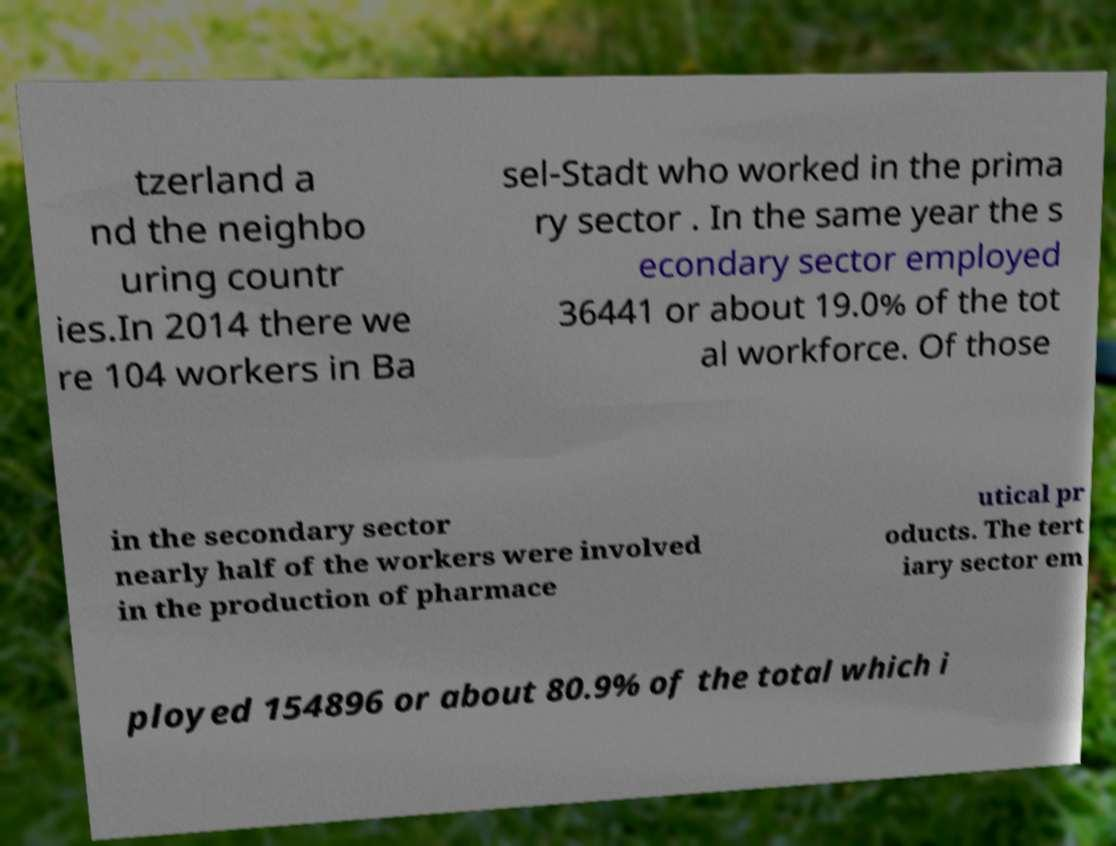What messages or text are displayed in this image? I need them in a readable, typed format. tzerland a nd the neighbo uring countr ies.In 2014 there we re 104 workers in Ba sel-Stadt who worked in the prima ry sector . In the same year the s econdary sector employed 36441 or about 19.0% of the tot al workforce. Of those in the secondary sector nearly half of the workers were involved in the production of pharmace utical pr oducts. The tert iary sector em ployed 154896 or about 80.9% of the total which i 